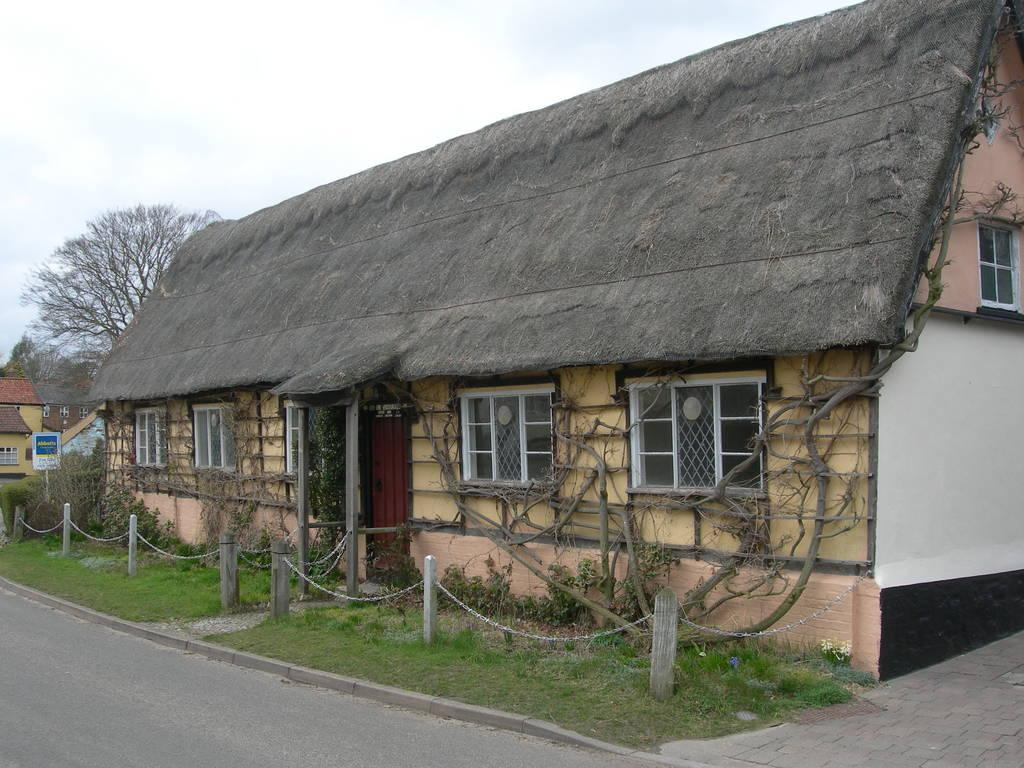What type of structures can be seen in the image? There are houses in the image. What natural elements are present in the image? There are many trees and plants in the image. What is visible in the sky in the image? There is a sky visible in the image. What type of surface can be seen in the image? There is a road in the image. What type of terrain is present in the image? There is grassy land in the image. Can you tell me how many bears are walking on the road in the image? There are no bears present in the image; it features houses, trees, plants, sky, road, and grassy land. What type of heat source can be seen in the image? There is no heat source visible in the image. 